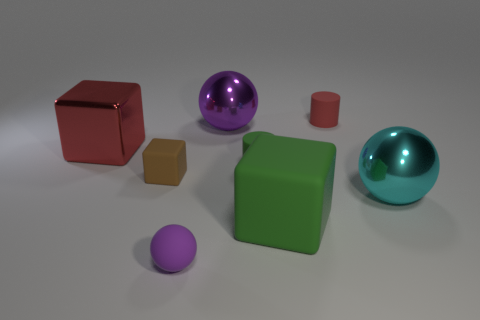Can you tell me the colors of the cylinders in the image? Certainly, there are two cylinders in the image: one is green and the other is a smaller one in red. 